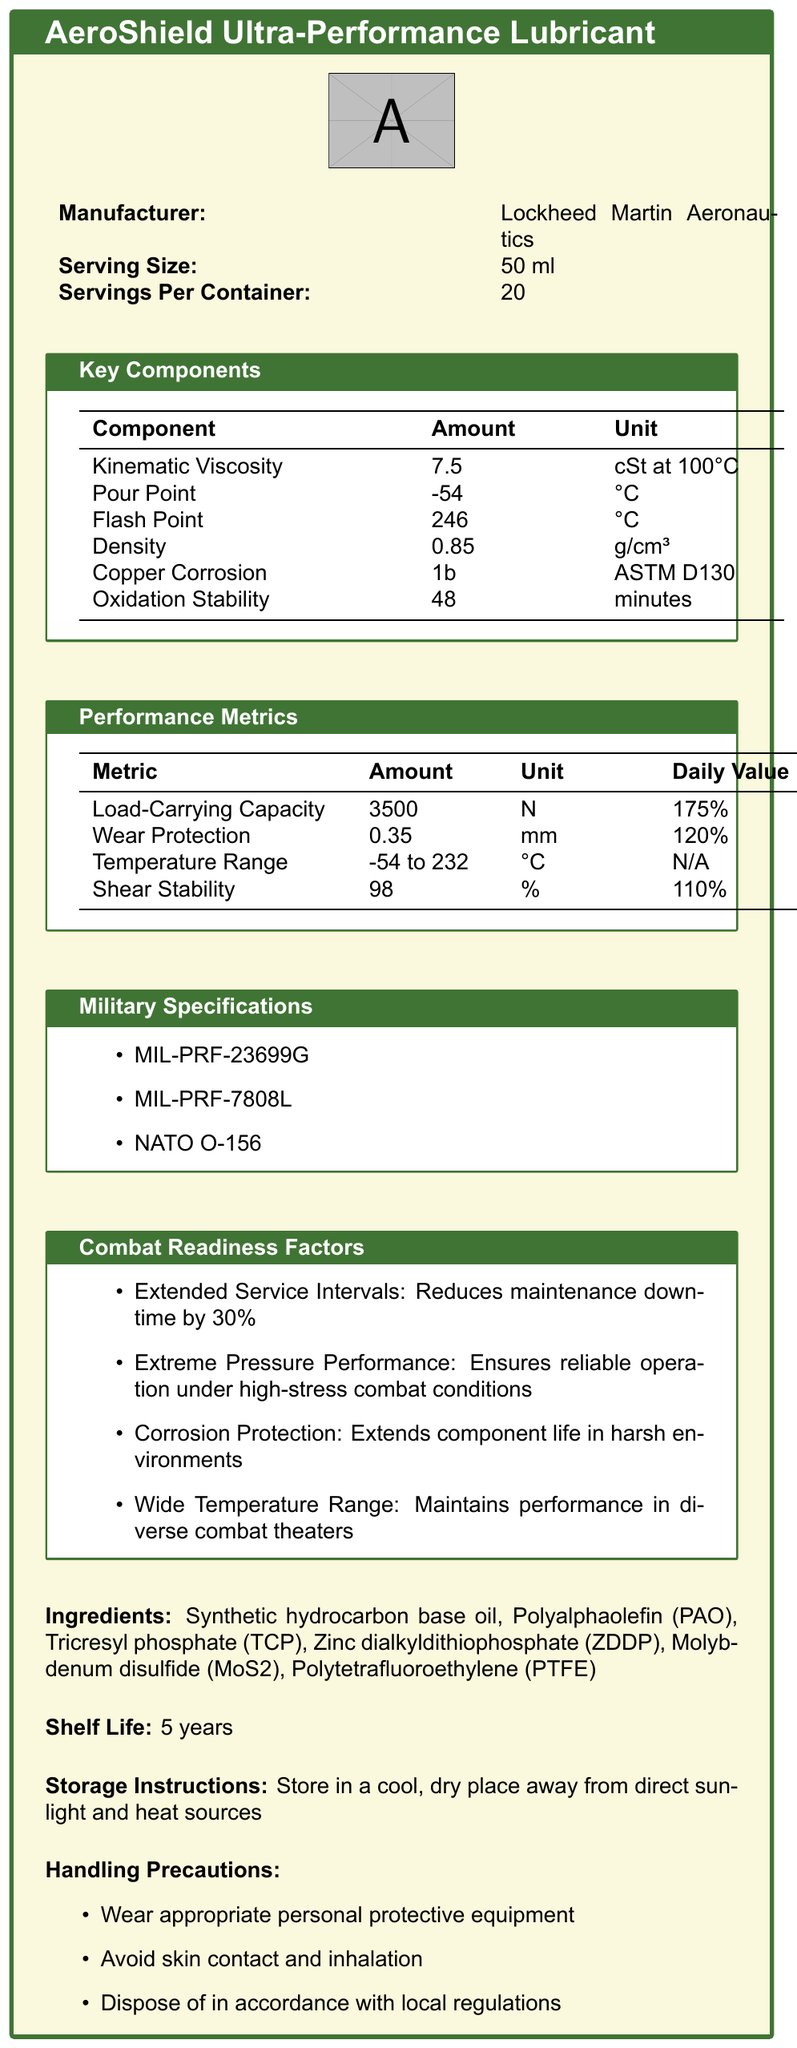What is the product name of the lubricant? The product name is explicitly listed at the top of the document.
Answer: AeroShield Ultra-Performance Lubricant Who is the manufacturer of AeroShield Ultra-Performance Lubricant? The manufacturer is specified in the document as Lockheed Martin Aeronautics.
Answer: Lockheed Martin Aeronautics How many servings are there per container? The document states that there are 20 servings per container.
Answer: 20 What is the serving size of AeroShield Ultra-Performance Lubricant? The serving size is noted as 50 ml in the document.
Answer: 50 ml List three ingredients found in the lubricant. These ingredients are part of a longer list which is provided in the document.
Answer: Synthetic hydrocarbon base oil, Polyalphaolefin (PAO), Tricresyl phosphate (TCP) What is the kinematic viscosity of the lubricant at 100°C? The kinematic viscosity at 100°C is given as 7.5 cSt in the key components section.
Answer: 7.5 cSt What is the pour point of the lubricant? The pour point of the lubricant is listed as -54 °C.
Answer: -54 °C What is the flash point of the lubricant? The document specifies the flash point as 246 °C.
Answer: 246 °C Which military specifications does the lubricant meet? A. MIL-PRF-23699G B. MIL-PRF-7808L C. NATO O-156 D. All of the above The lubricant meets all three specified military specifications: MIL-PRF-23699G, MIL-PRF-7808L, and NATO O-156.
Answer: D. All of the above How long is the shelf life of the lubricant? The shelf life is clearly stated to be 5 years.
Answer: 5 years What is the temperature range for the lubricant’s performance? A. -50 to 240 °C B. -54 to 232 °C C. -55 to 220 °C D. -60 to 230 °C The document lists the temperature range of the lubricant’s performance as -54 to 232 °C.
Answer: B. -54 to 232 °C Does the document provide the price of the lubricant? The document does not include information on the price of the lubricant.
Answer: Cannot be determined Summarize the entire document. The document includes a comprehensive overview of the lubricant’s specifications and benefits, targeting aerospace and military applications, with specific data on physical properties, performance metrics, and adherence to several military and industry standards.
Answer: The document provides detailed information about AeroShield Ultra-Performance Lubricant, including its manufacturer, key components, performance metrics, military specifications, combat readiness factors, ingredients, shelf life, storage instructions, and handling precautions. This aerospace-grade lubricant is designed to improve maintenance efficiency, perform under extreme conditions, and protect against corrosion. Is Zinc dialkyldithiophosphate (ZDDP) listed as an ingredient in the lubricant? The ingredient list includes Zinc dialkyldithiophosphate (ZDDP).
Answer: Yes By what percentage does the AeroShield Ultra-Performance Lubricant reduce maintenance downtime? One of the combat readiness factors mentions that the lubricant reduces maintenance downtime by 30%.
Answer: 30% True or False: The document mentions that the lubricant comes with a warranty. The document does not mention any warranty associated with the lubricant.
Answer: False What performance metric shows a daily value of 120%? The document shows that the Wear Protection metric is listed with a daily value of 120%.
Answer: Wear Protection Which certification mentioned in the document is not from a military entity? The certification General Electric D50TF1 is not from a military entity, unlike the other military specifications mentioned.
Answer: General Electric D50TF1 